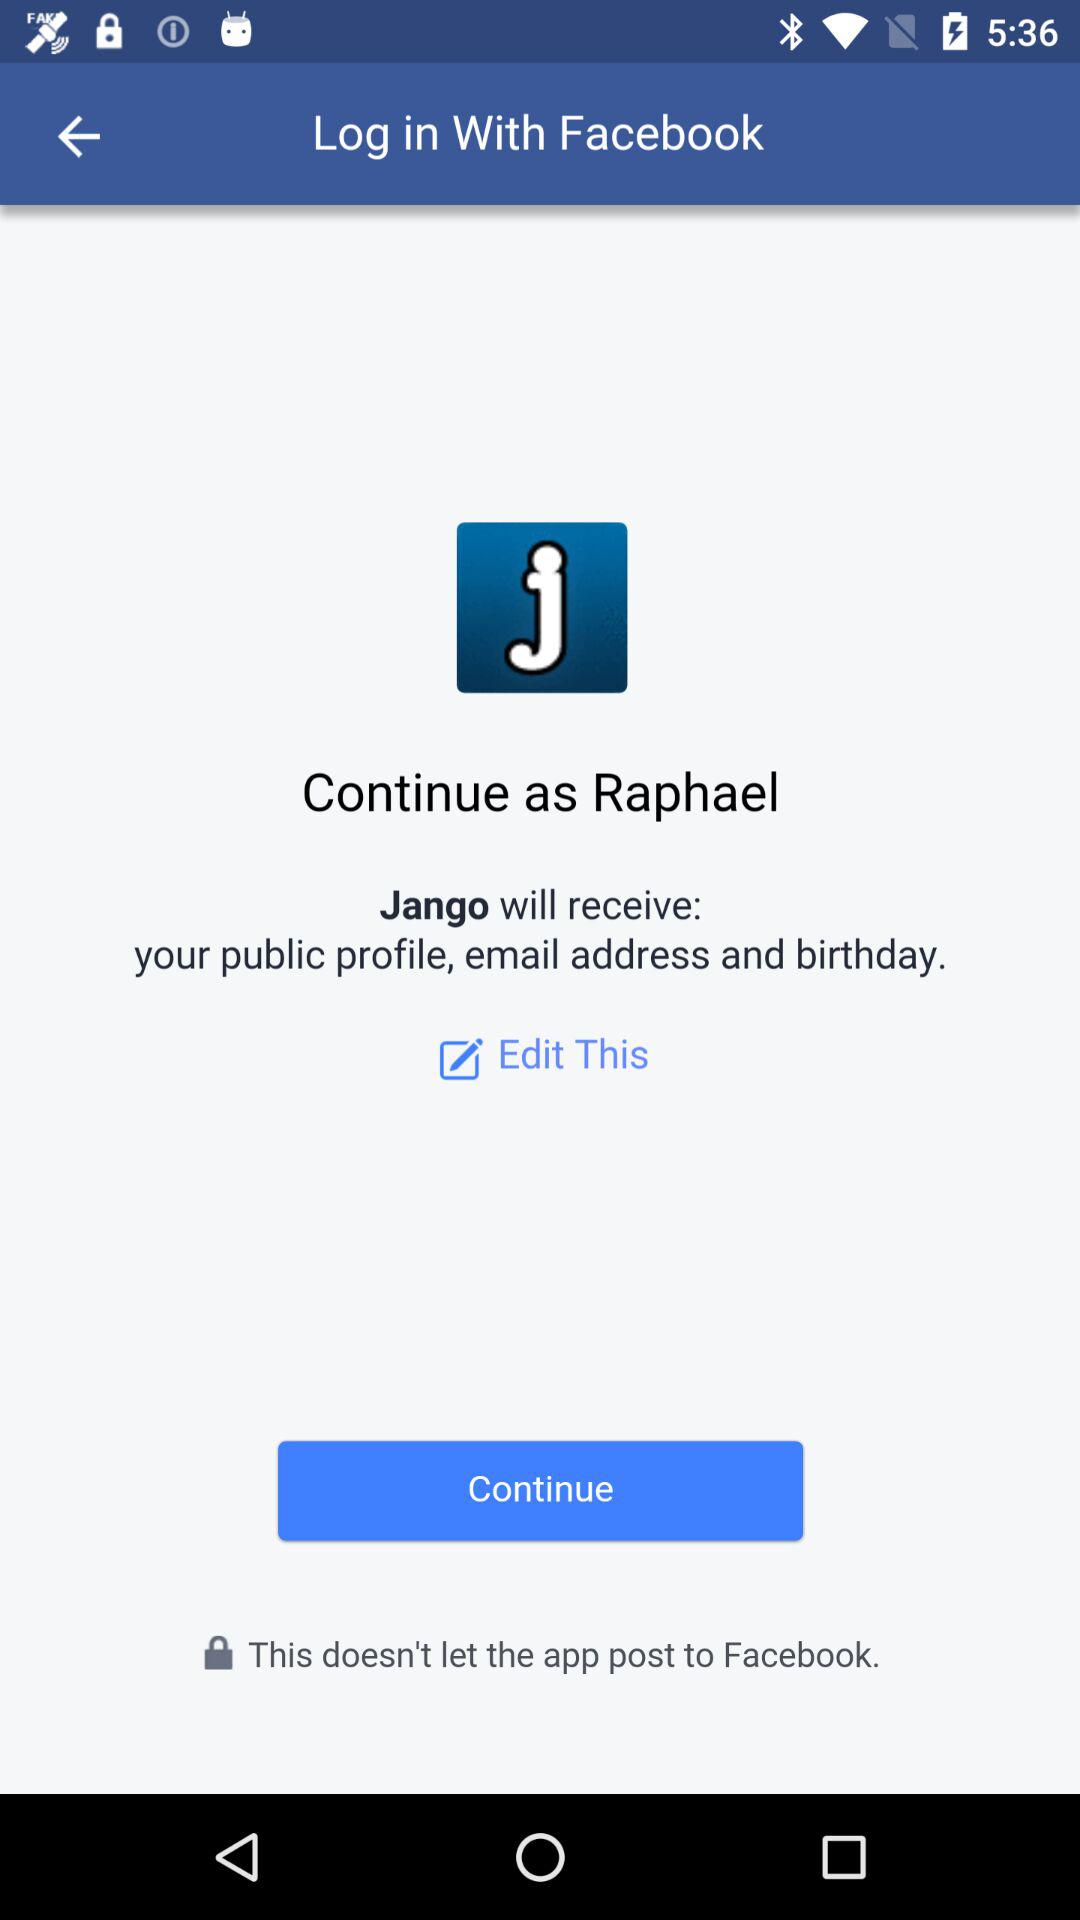What information does the app request access to when logging in? The app requests access to your public profile, email address, and birthday. 